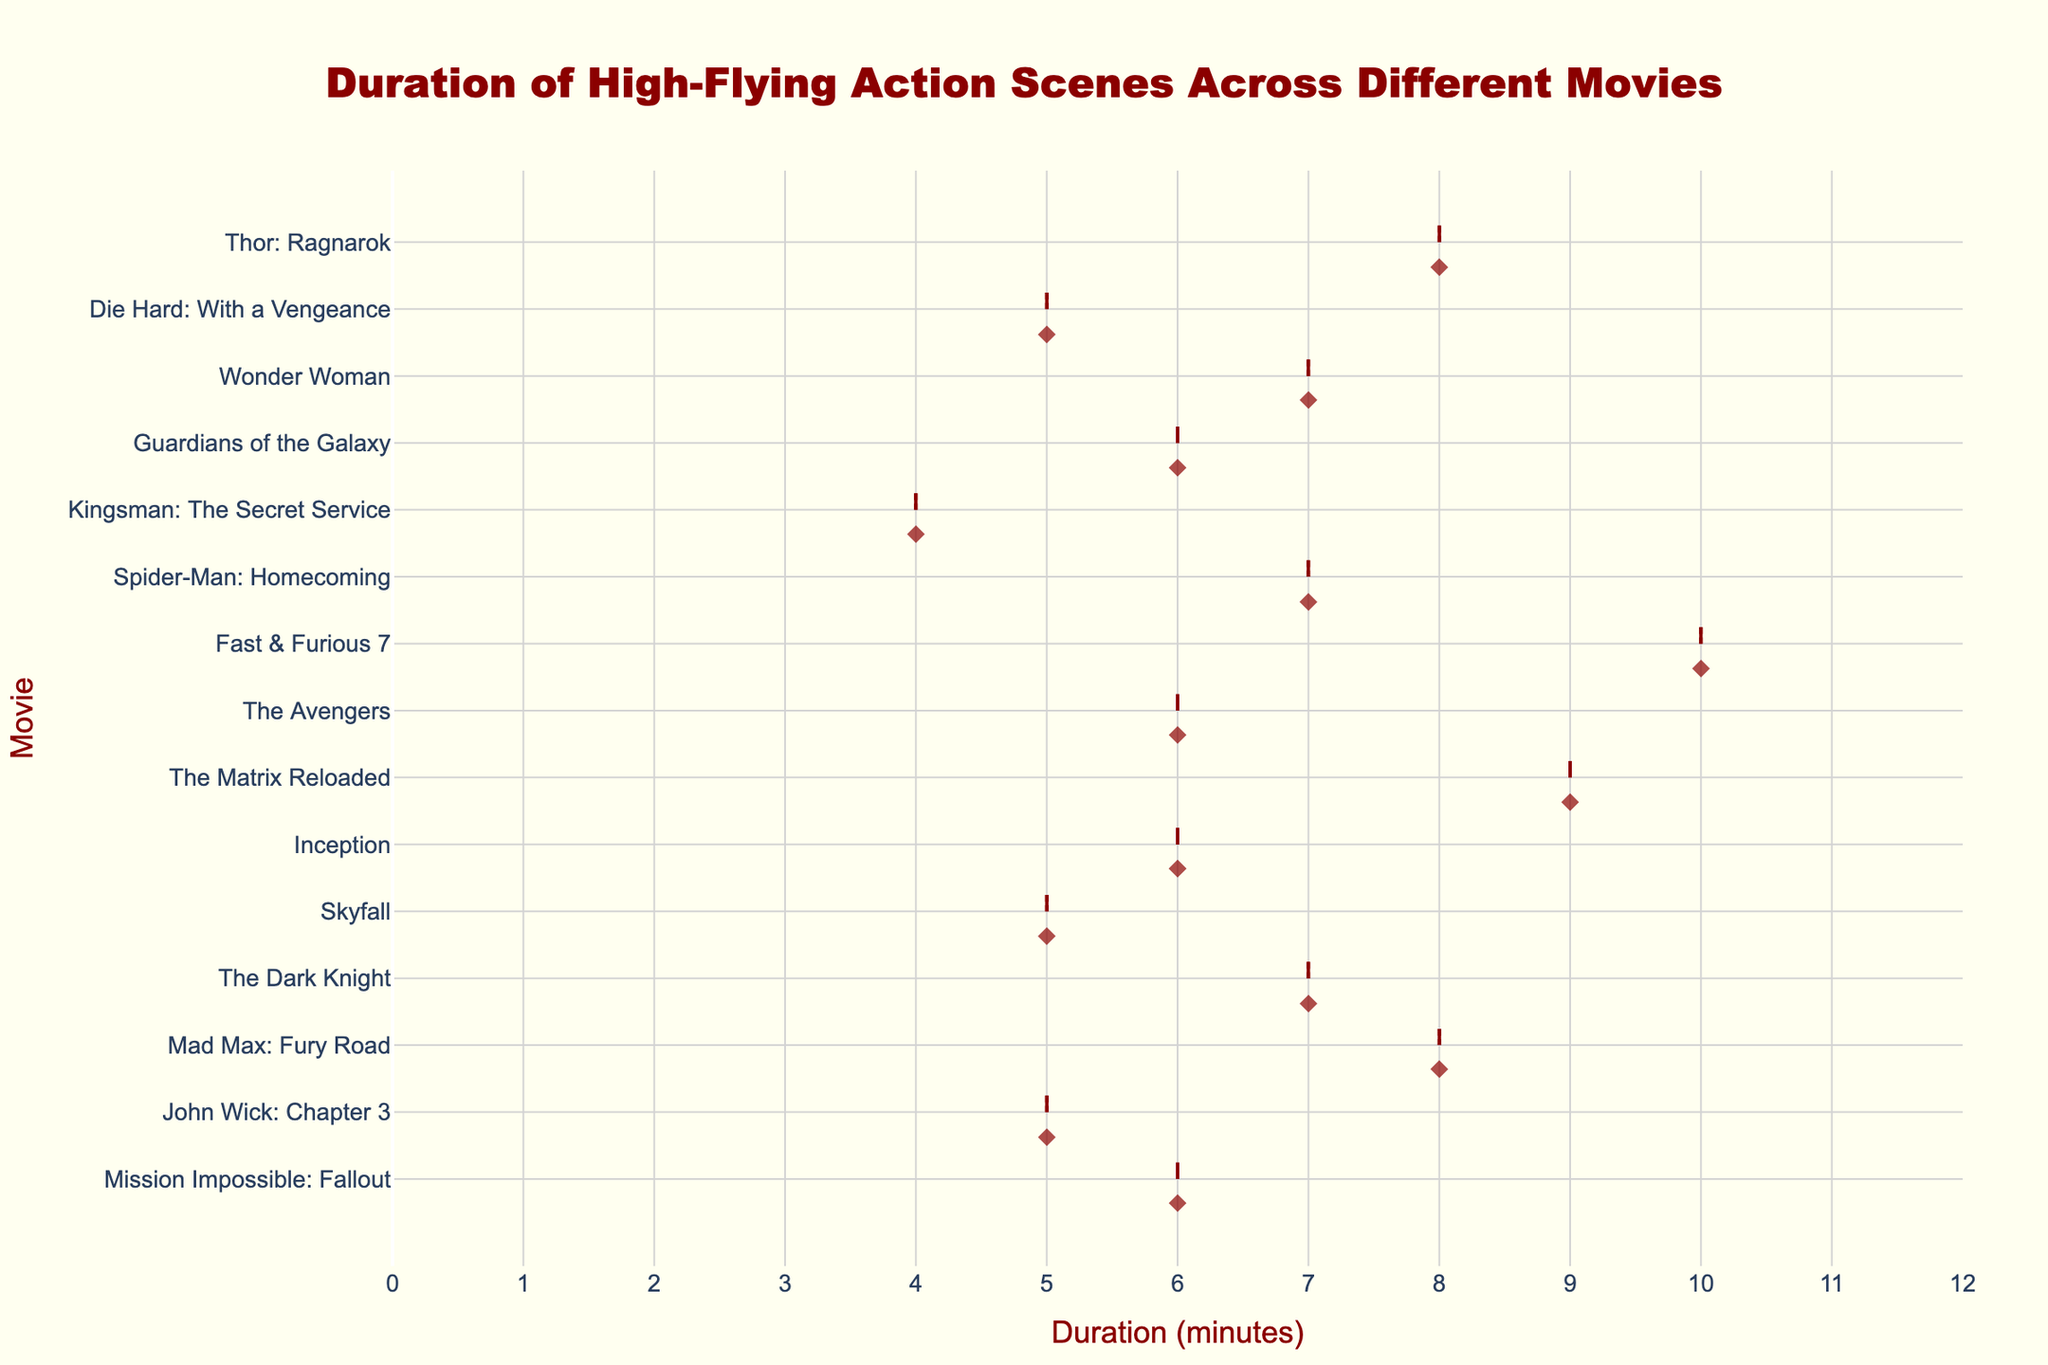How many movies have a high-flying action scene lasting exactly 6 minutes? Count the number of points on the horizontal violin chart that align with the 6-minute duration.
Answer: 4 Which movie has the longest high-flying action scene? Identify the highest point on the horizontal axis (duration) and check which movie it corresponds to.
Answer: Fast & Furious 7 What is the median duration of high-flying action scenes across all movies? Arrange the durations in ascending order and find the middle value. Ordered durations: 4, 5, 5, 5, 6, 6, 6, 6, 7, 7, 7, 7, 8, 8, 9, 10. The median is the average of the 8th and 9th values (6 and 7), so median = (6+7)/2 = 6.5.
Answer: 6.5 Which movies have a high-flying action scene lasting more than 8 minutes? Look for points on the horizontal violin chart that are above the 8-minute mark and note the corresponding movies.
Answer: The Matrix Reloaded, Fast & Furious 7 What is the range of durations for high-flying action scenes? Determine the difference between the maximum and minimum values of the durations shown on the horizontal axis. The maximum is 10 (Fast & Furious 7) and the minimum is 4 (Kingsman: The Secret Service), so the range is 10 - 4 = 6.
Answer: 6 Which movie has the shortest high-flying action scene? Identify the lowest point on the horizontal axis (duration) and check which movie it corresponds to.
Answer: Kingsman: The Secret Service How many movies have high-flying action scenes of 7 minutes? Count the number of points on the horizontal violin chart that align with the 7-minute duration.
Answer: 4 What is the average duration of high-flying action scenes across all movies? Sum all the durations and divide by the number of movies. Sum = 6+5+8+7+5+6+9+6+10+7+4+6+7+5+8 = 99. Number of movies = 15. Average = 99/15 = 6.6.
Answer: 6.6 Is the distribution of durations skewed more towards shorter or longer high-flying action scenes? Observe the spread of the data points on the horizontal violin chart. If most points are nearer to the lower or higher end of the duration scale, the distribution is skewed accordingly.
Answer: Shorter 